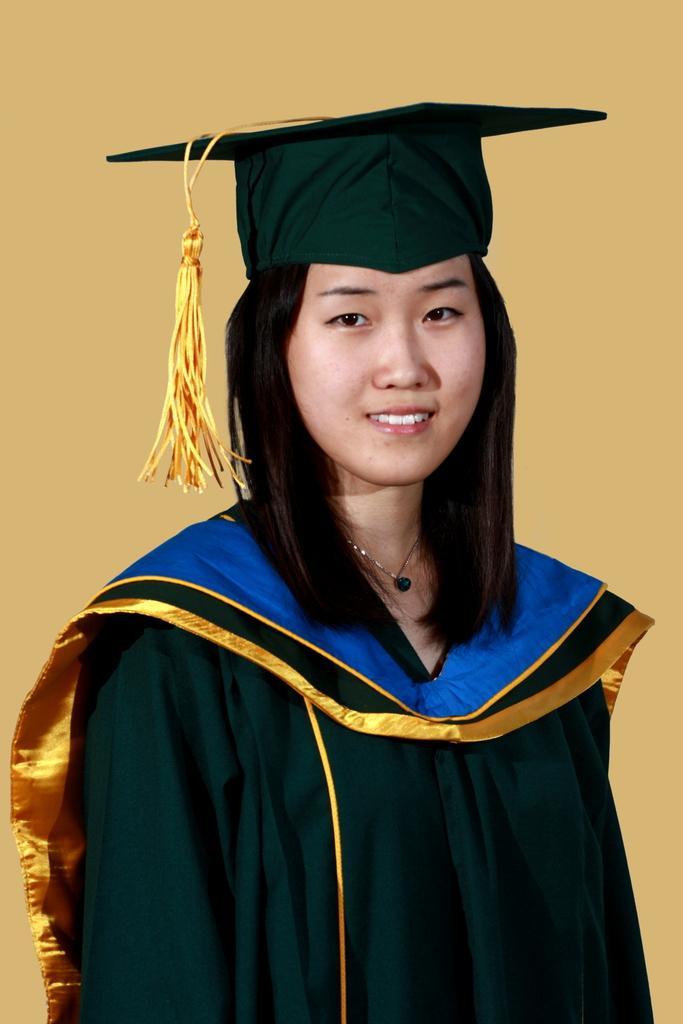Could you give a brief overview of what you see in this image? A beautiful woman is standing, she wore a black color coat, cap. 